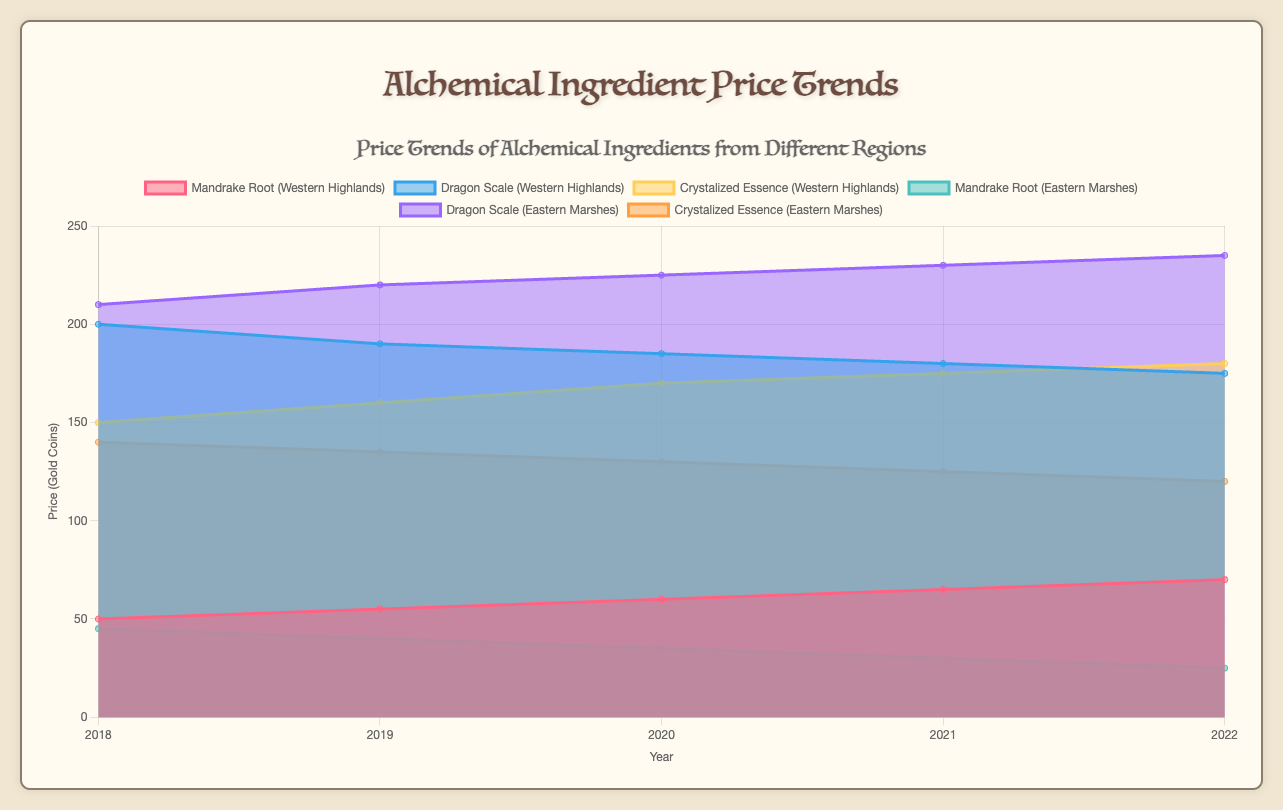What is the title of the chart? The title is prominently displayed at the top of the chart and provides an overview of what the chart represents.
Answer: Alchemical Ingredient Price Trends How many data points are represented for each ingredient from the Western Highlands? For each ingredient from the Western Highlands, there are data points for the years 2018, 2019, 2020, 2021, and 2022, which totals to 5 data points per ingredient.
Answer: 5 Which ingredient from the Western Highlands had the highest price in 2018? By looking at the data representation for the year 2018 among the ingredients from the Western Highlands, Dragon Scale had the highest price with an average of 200 gold coins.
Answer: Dragon Scale What's the trend for the price of Mandrake Root in the Eastern Marshes from 2018 to 2022? Observing the Mandrake Root data for the Eastern Marshes, the prices decreased consistently over these years from 45 to 25 gold coins.
Answer: Decreasing What is the difference between the highest price of Dragon Scale in the Eastern Marshes and the lowest price of Mandrake Root in the Western Highlands between 2018 and 2022? The highest price of Dragon Scale in Eastern Marshes is 235 (2022), and the lowest price of Mandrake Root in Western Highlands is 50 (2018). Therefore, the difference is 235 - 50 = 185 gold coins.
Answer: 185 Which ingredient had the most consistent price trend in the Western Highlands over the years? Looking at the Western Highlands' ingredient data, Crystalized Essence had a steadily increasing price trend from 150 to 180 without much fluctuation.
Answer: Crystalized Essence In which year did the Eastern Marshes have the highest price disparity among the three ingredients? To find the year with the highest price disparity in Eastern Marshes, compare the differences within each year. In 2022, the disparity between Dragon Scale (235) and Mandrake Root (25) is the highest (210).
Answer: 2022 Between the two regions, which had a higher average price for Crystalized Essence over the years? Calculating the average prices: 
Western Highlands: (150 + 160 + 170 + 175 + 180) / 5 = 167.  
Eastern Marshes: (140 + 135 + 130 + 125 + 120) / 5 = 130.
167 is higher than 130.
Answer: Western Highlands Which ingredient in Eastern Marshes had its price increased the most from 2018 to 2022? By comparing the price changes for each ingredient from 2018 to 2022: Mandrake Root (-45 to 25, decrease of 20), Dragon Scale (210 to 235, increase of 25), Crystalized Essence (140 to 120, decrease of 20). The Dragon Scale had the most significant increase of 25 gold coins.
Answer: Dragon Scale How does the price trend of Dragon Scale compare between the Western Highlands and Eastern Marshes? In Western Highlands, the price of Dragon Scale decreases from 200 to 175, while in Eastern Marshes, the price increases from 210 to 235. They show opposite trends.
Answer: Opposite trends 